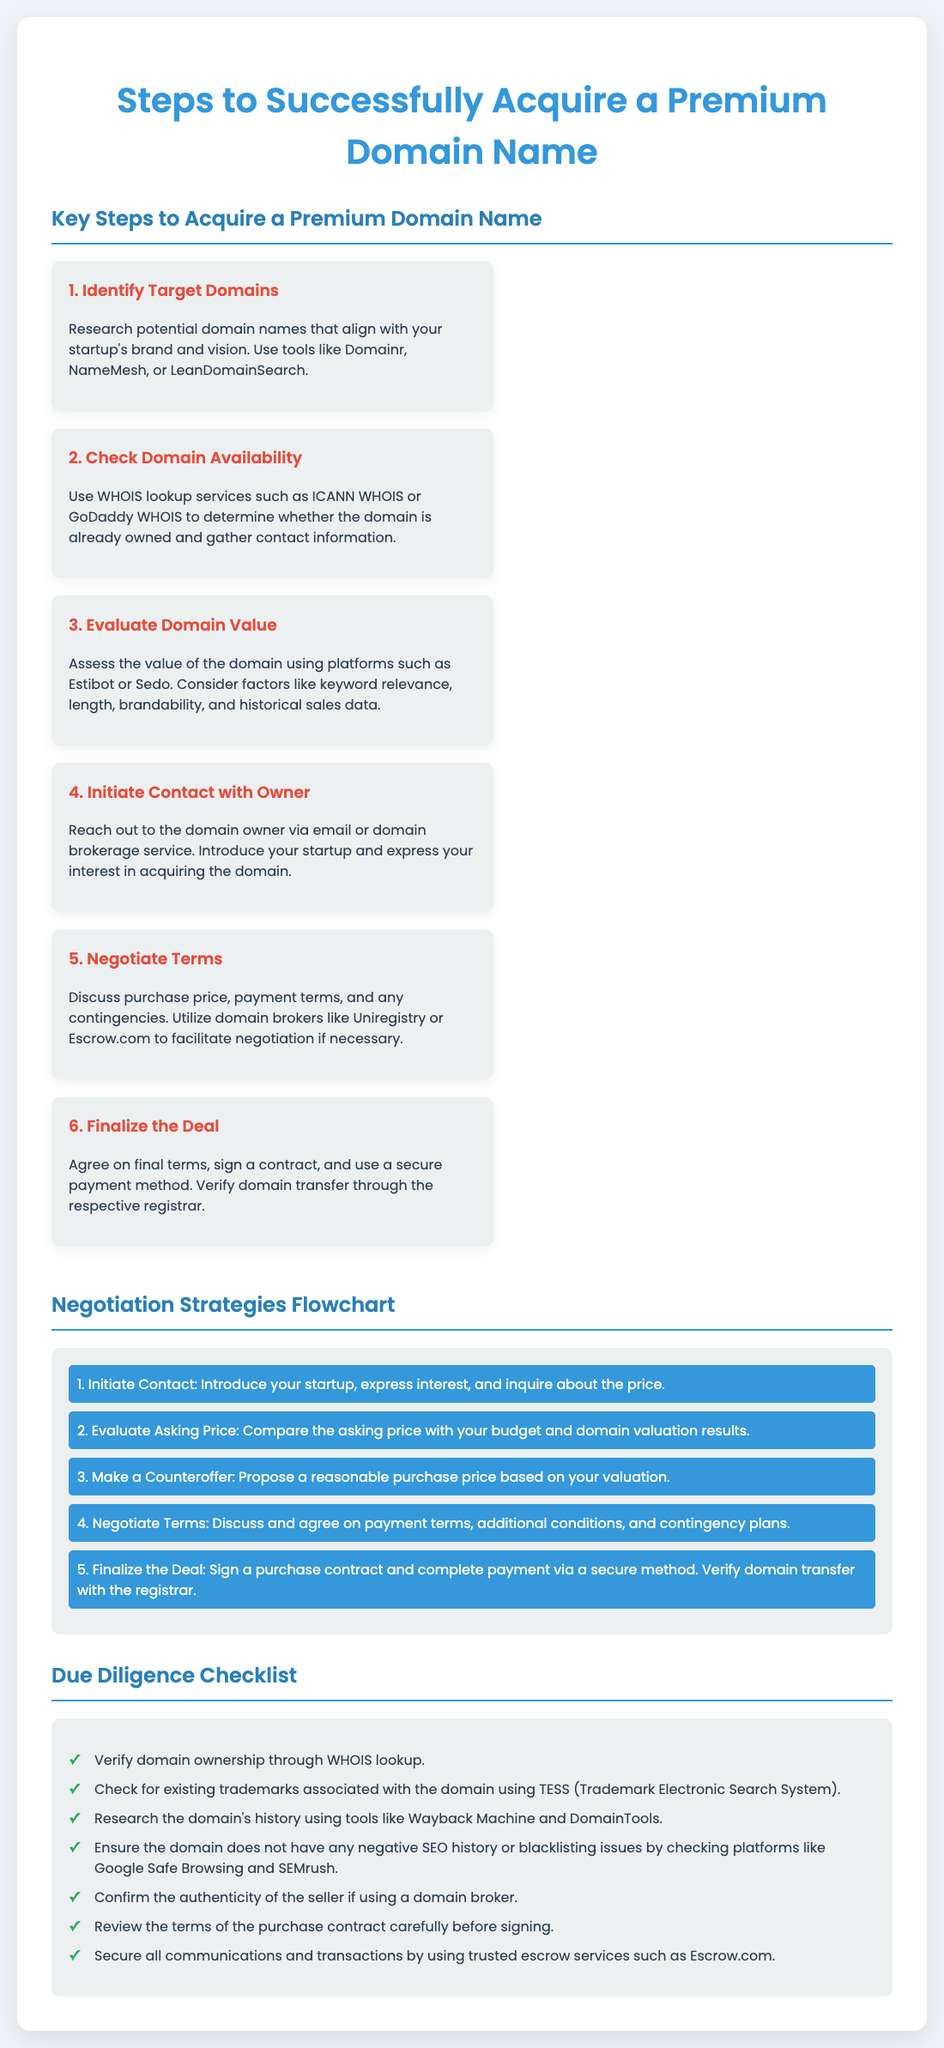What is the first step to acquire a premium domain name? The first step listed in the document is to identify target domains.
Answer: Identify Target Domains What tools can be used to research potential domain names? The document mentions tools like Domainr, NameMesh, or LeanDomainSearch for this purpose.
Answer: Domainr, NameMesh, LeanDomainSearch What is one platform for evaluating domain value? The document lists platforms such as Estibot or Sedo for assessing domain value.
Answer: Estibot How many steps are there to acquire a premium domain name? The document outlines a total of six key steps in the process.
Answer: Six In the first flowchart step, what should you do? The first step in the negotiation strategies flowchart is to initiate contact.
Answer: Initiate Contact What is listed as a tool to research domain history? The document suggests using the Wayback Machine to research domain history.
Answer: Wayback Machine Name one check to perform during due diligence. The document mentions verifying domain ownership through WHOIS lookup as a checklist item.
Answer: Verify domain ownership How should communications and transactions be secured? The document advises using trusted escrow services like Escrow.com for secure transactions.
Answer: Escrow.com What color is used for the title "Negotiation Strategies Flowchart"? The title is in a background color of light gray as part of the flowchart section.
Answer: Light gray 